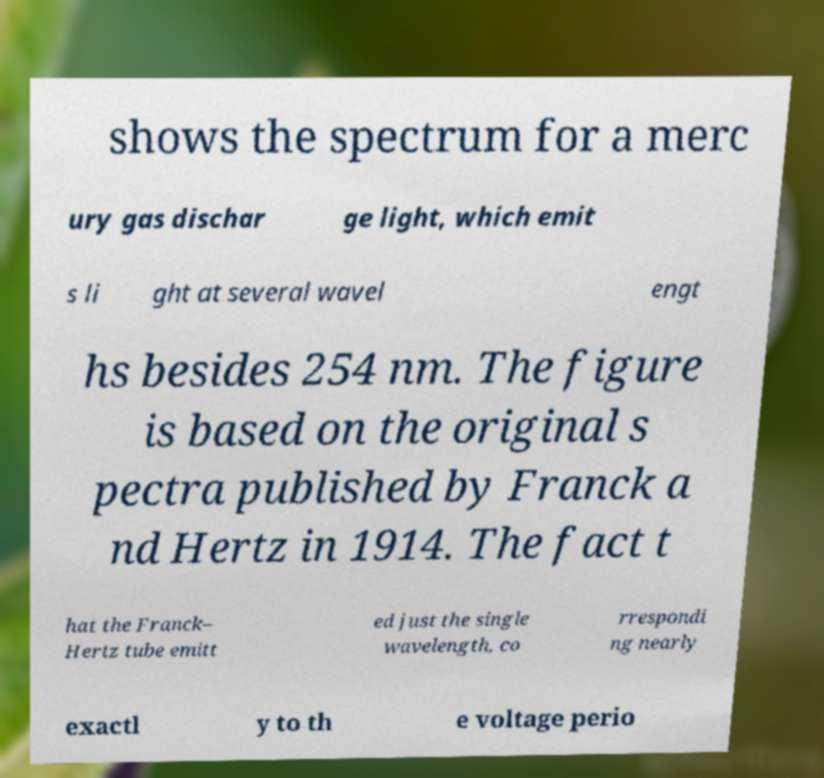There's text embedded in this image that I need extracted. Can you transcribe it verbatim? shows the spectrum for a merc ury gas dischar ge light, which emit s li ght at several wavel engt hs besides 254 nm. The figure is based on the original s pectra published by Franck a nd Hertz in 1914. The fact t hat the Franck– Hertz tube emitt ed just the single wavelength, co rrespondi ng nearly exactl y to th e voltage perio 